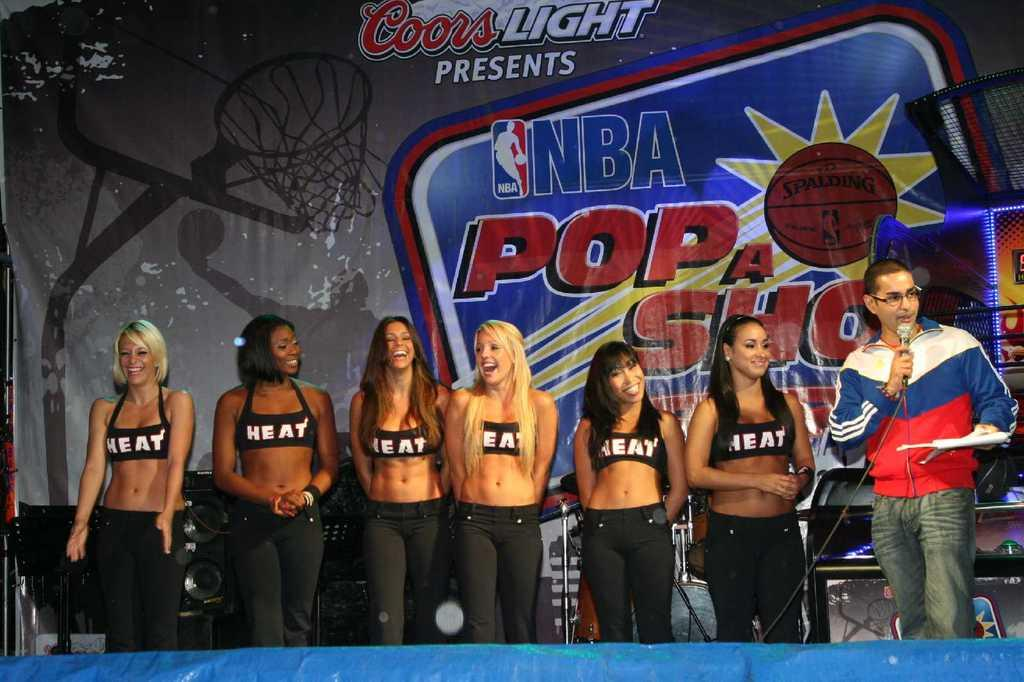<image>
Present a compact description of the photo's key features. an NBA sign is near some of the players 